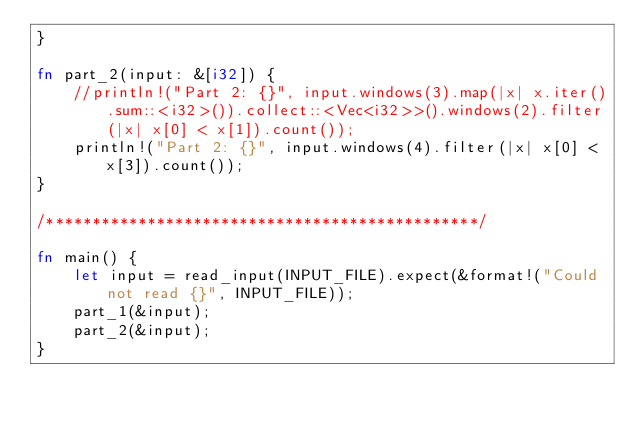<code> <loc_0><loc_0><loc_500><loc_500><_Rust_>}

fn part_2(input: &[i32]) {
    //println!("Part 2: {}", input.windows(3).map(|x| x.iter().sum::<i32>()).collect::<Vec<i32>>().windows(2).filter(|x| x[0] < x[1]).count());
    println!("Part 2: {}", input.windows(4).filter(|x| x[0] < x[3]).count());
}

/***********************************************/

fn main() {
    let input = read_input(INPUT_FILE).expect(&format!("Could not read {}", INPUT_FILE));
    part_1(&input);
    part_2(&input);
}
</code> 